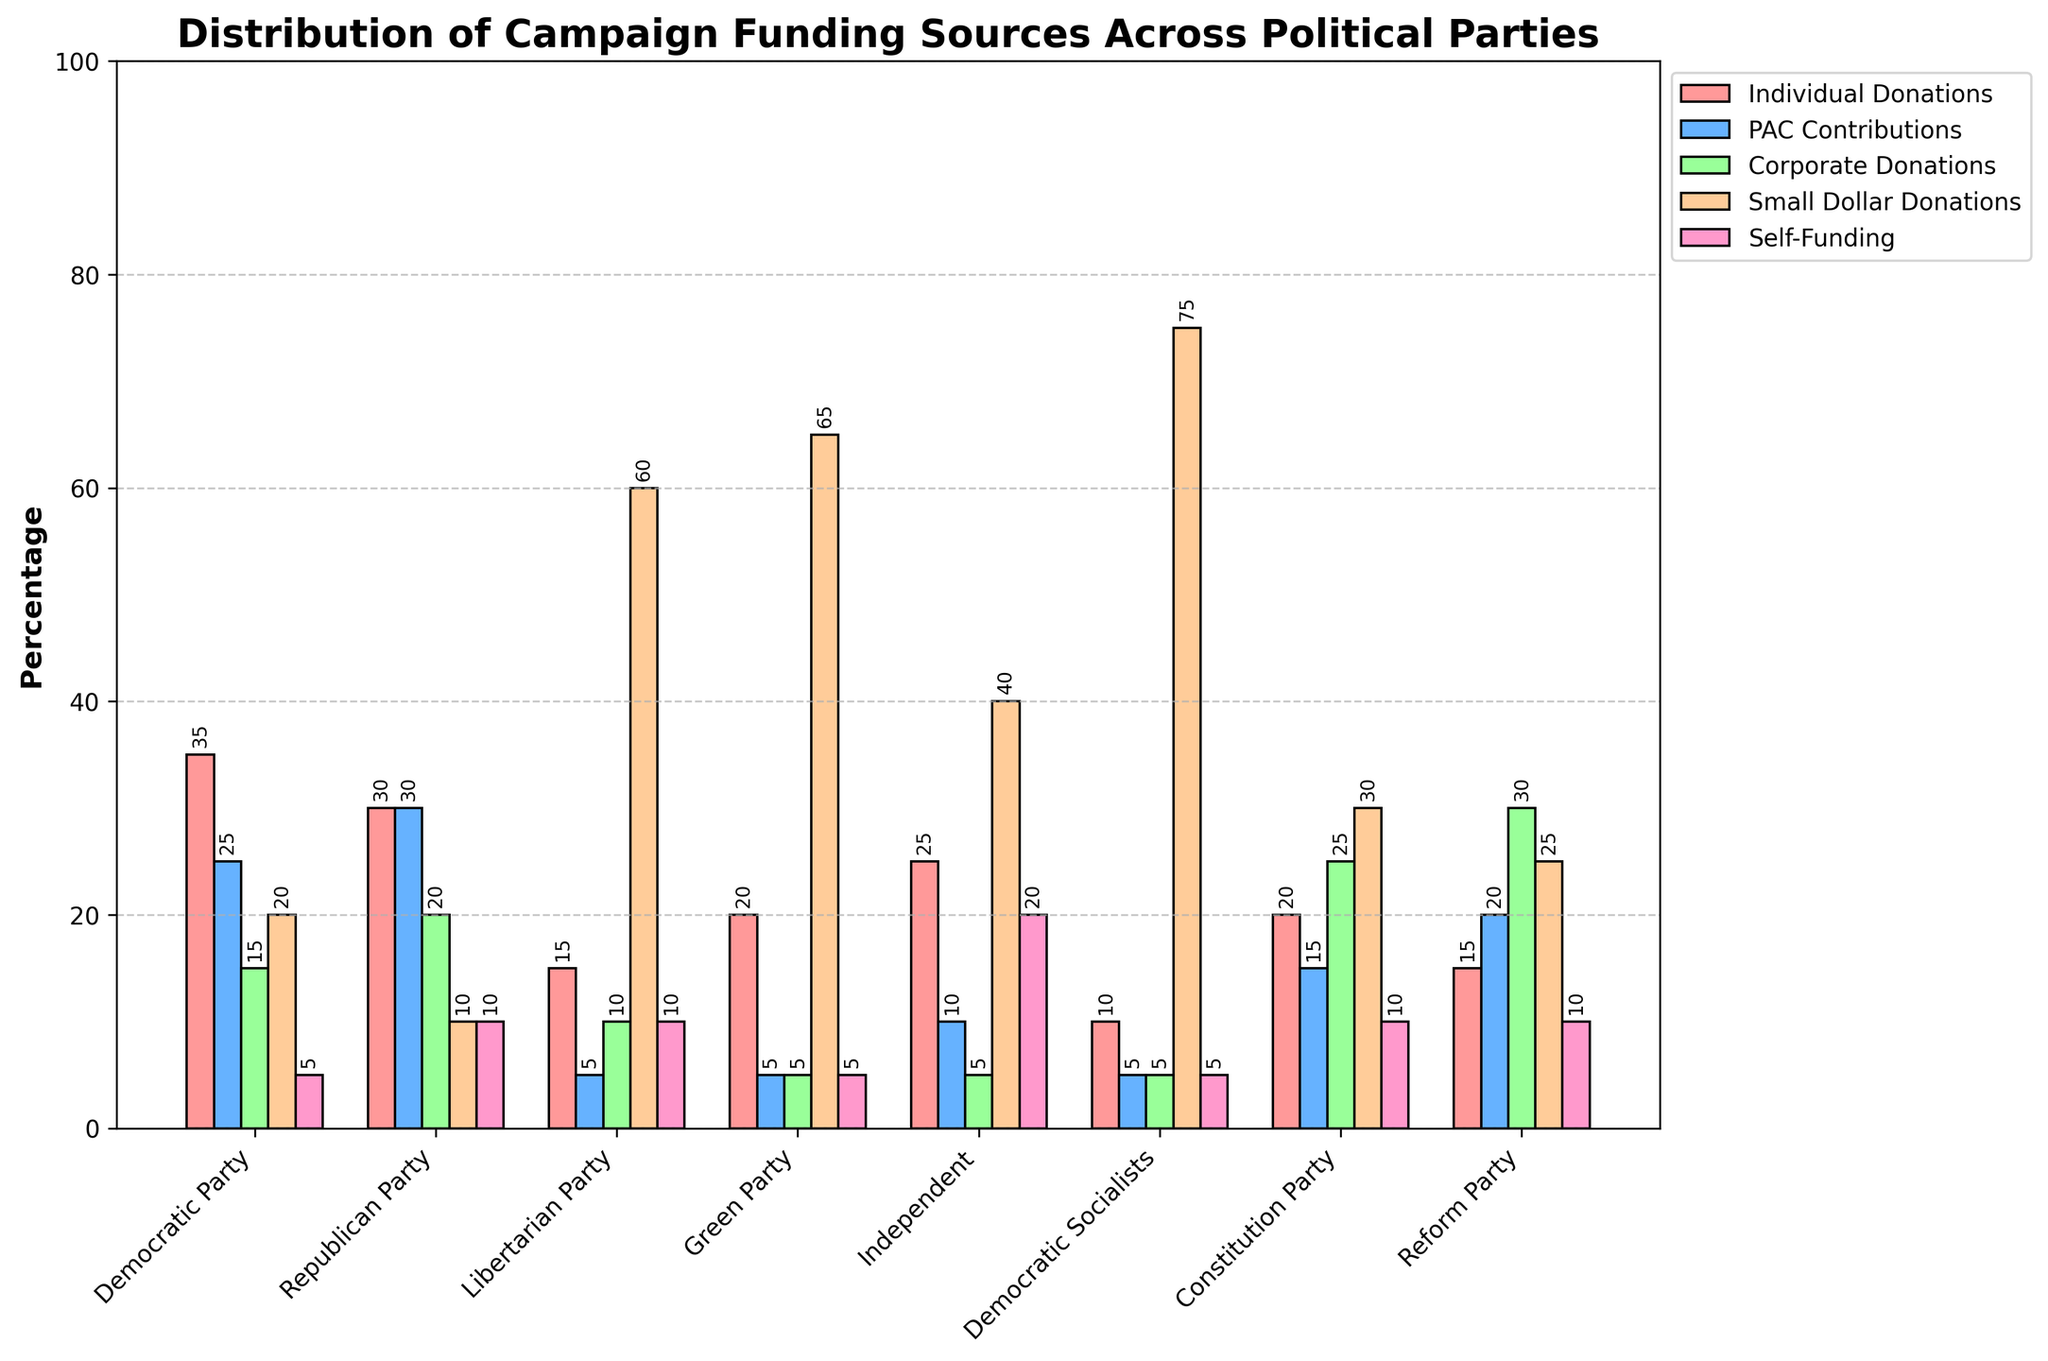What's the funding source that constitutes the highest percentage for the Green Party? To find the highest percentage funding source for the Green Party, look at the tallest bar in the cluster corresponding to the Green Party. The highest bar is for Small Dollar Donations.
Answer: Small Dollar Donations Which political party has the largest self-funding percentage? Compare the bars for Self-Funding across all parties. The highest bar is with Independent Party.
Answer: Independent Party What is the combined percentage of Individual Donations and Corporate Donations for the Democratic Party? For the Democratic Party, add the percentages of Individual Donations (35%) and Corporate Donations (15%). The sum is 35% + 15%.
Answer: 50% Which party has a higher percentage of PAC Contributions, Republican or Democratic? Compare the bars for PAC Contributions between the Republican and Democratic parties. The Republican Party has 30%, and the Democratic Party has 25%.
Answer: Republican Party How does the percentage of Small Dollar Donations for the Democratic Socialists compare to that of the Libertarian Party? Compare the height of the Small Dollar Donations bar for the Democratic Socialists (75%) to that of the Libertarian Party (60%). Democratic Socialists have a higher percentage.
Answer: Democratic Socialists What is the average percentage of Corporate Donations across all parties? Add the Corporate Donations percentages across all parties and divide by the number of parties: (15% + 20% + 10% + 5% + 5% + 5% + 25% + 30%) / 8 = 14.375%
Answer: 14.375% For which funding source does the Democratic Party have the lowest percentage? Identify the shortest bar in the Democratic Party cluster. The shortest is Self-Funding at 5%.
Answer: Self-Funding Which party has the greatest disparity between Individual Donations and Small Dollar Donations? Calculate the difference between Individual Donations and Small Dollar Donations for each party, then compare these differences. The highest difference is for the Democratic Socialists with 75% - 10% = 65%.
Answer: Democratic Socialists What is the difference in the percentage of Corporate Donations between the Reform Party and the Constitution Party? Subtract the Corporate Donations percentage of the Constitution Party (25%) from the Corporate Donations percentage of the Reform Party (30%). The difference is 30% - 25%.
Answer: 5% 